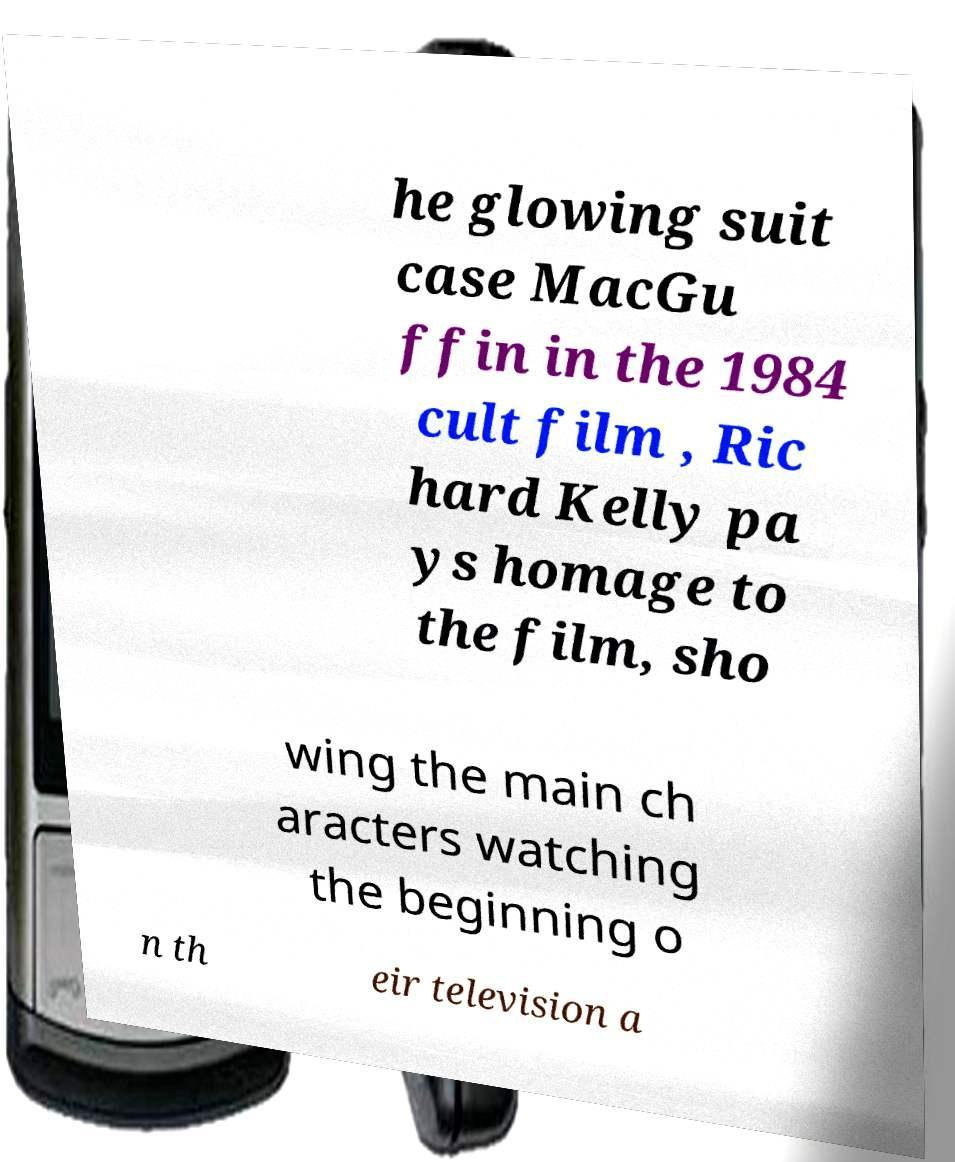For documentation purposes, I need the text within this image transcribed. Could you provide that? he glowing suit case MacGu ffin in the 1984 cult film , Ric hard Kelly pa ys homage to the film, sho wing the main ch aracters watching the beginning o n th eir television a 